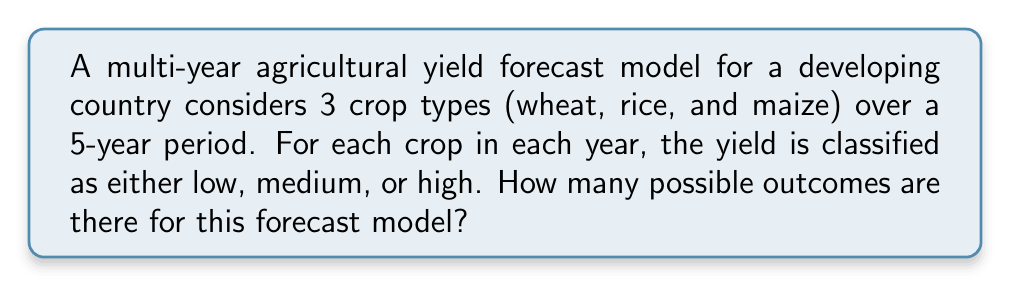Solve this math problem. Let's approach this step-by-step:

1) First, we need to identify the key components of the problem:
   - We have 3 crop types
   - We are forecasting for 5 years
   - Each crop in each year can have 3 possible yield outcomes (low, medium, high)

2) For each crop in a single year, we have 3 possibilities.

3) We need to consider this for all 3 crops in that year. This is equivalent to making 3 independent choices, each with 3 possibilities. The number of outcomes for one year is thus:

   $$ 3 \times 3 \times 3 = 3^3 = 27 $$

4) Now, we need to consider this for all 5 years. This is equivalent to making 5 independent choices, each with 27 possibilities. We can use the multiplication principle of combinatorics:

   $$ 27 \times 27 \times 27 \times 27 \times 27 = 27^5 $$

5) We can simplify this further:

   $$ 27^5 = (3^3)^5 = 3^{15} $$

6) Calculate the final result:

   $$ 3^{15} = 14,348,907 $$

Thus, there are 14,348,907 possible outcomes for this forecast model.
Answer: $3^{15} = 14,348,907$ 